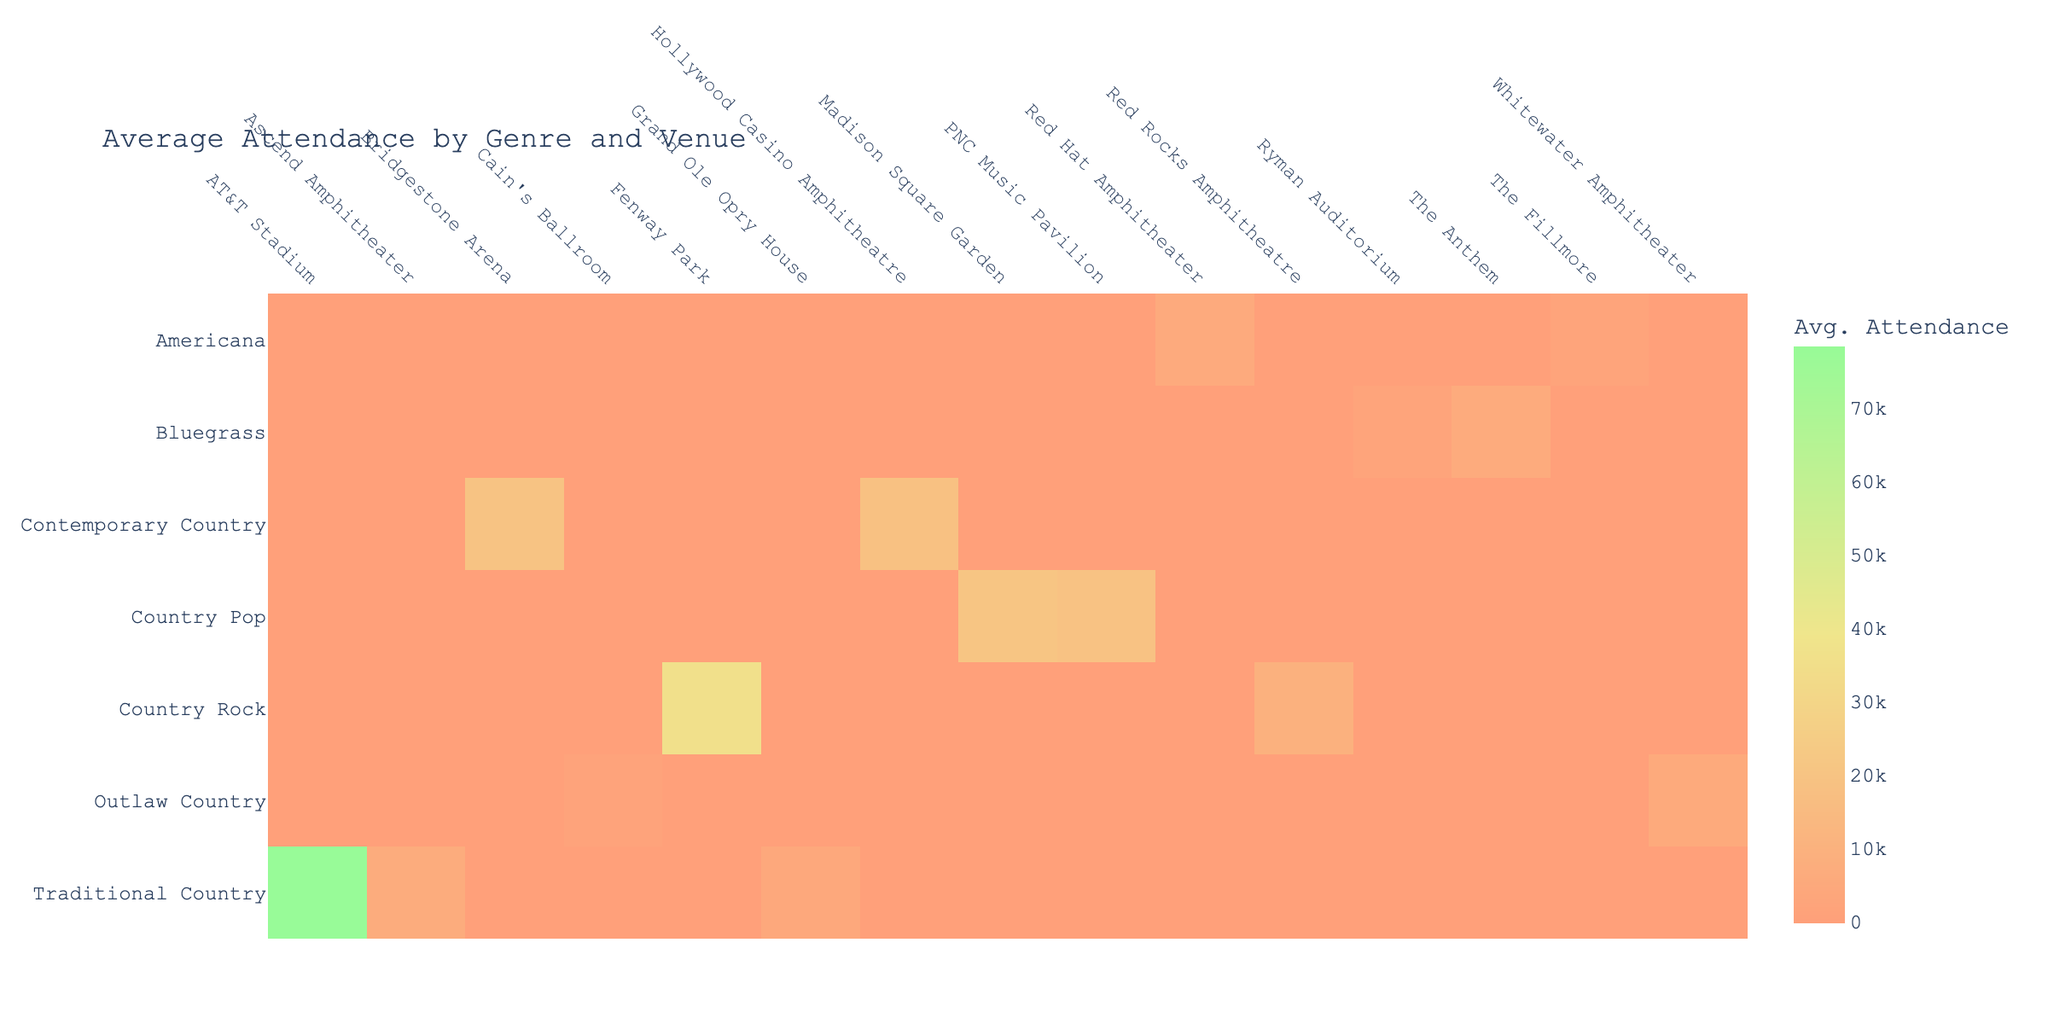What is the average attendance for Traditional Country concerts? To find the average attendance for Traditional Country concerts, we look at the attendance values for the artists in that genre, which are: George Strait (78500), Alan Jackson (4350), and Dolly Parton (6750). We sum these values: 78500 + 4350 + 6750 = 88500, and then divide by the number of concerts held (3). Thus, 88500 / 3 = 29500.
Answer: 29500 Which venue had the highest average attendance across all genres? To determine the venue with the highest average attendance, we look at the average attendance for each venue. The values are: AT&T Stadium (78500), Bridgestone Arena (19800), Red Rocks Amphitheatre (9450), Ryman Auditorium (2300), Whitewater Amphitheater (5400), Madison Square Garden (20500), The Fillmore (2450), Grand Ole Opry House (4350), Hollywood Casino Amphitheatre (18500), Fenway Park (36000), The Anthem (5900), Cain's Ballroom (1750), PNC Music Pavilion (19000), Red Hat Amphitheater (5800), and Ascend Amphitheater (6750). The highest value among these is for AT&T Stadium at 78500.
Answer: AT&T Stadium Is there any venue where all concerts had attendance lower than its capacity? To find such venues, we need to check each attendance against its capacity. For all concerts where attendance is less than capacity: AT&T Stadium (78500 vs 80000), Bridgestone Arena (19800 vs 20000), Red Rocks Amphitheatre (9450 vs 9500), Ryman Auditorium (2300 vs 2362), Whitewater Amphitheater (5400 vs 5600), Madison Square Garden (20500 vs 20789), The Fillmore (2450 vs 2500), Grand Ole Opry House (4350 vs 4400), Hollywood Casino Amphitheatre (18500 vs 19000), Fenway Park (36000 vs 37731), The Anthem (5900 vs 6000), Cain's Ballroom (1750 vs 1800), PNC Music Pavilion (19000 vs 19500), Red Hat Amphitheater (5800 vs 5990), Ascend Amphitheater (6750 vs 6800). Since all venues have at least one concert with attendance lower than capacity, the answer is yes.
Answer: Yes What is the total attendance for concerts held in Nashville? To calculate the total attendance for concerts in Nashville, we list the artists and their attendance from that city: Luke Bryan (19800), Alison Krauss (2300), Alan Jackson (4350), Miranda Lambert (18500), Dolly Parton (6750). We sum these values: 19800 + 2300 + 4350 + 18500 + 6750 = 51000.
Answer: 51000 Which genre had the lowest average attendance overall? We need to calculate the average attendance for each genre by summing the attendance values and dividing by the number of concerts for each genre. The averages are: Traditional Country (29500), Contemporary Country (19150), Country Rock (22725), Bluegrass (1450), Outlaw Country (3650), Country Pop (19750), Americana (3290). The genre with the lowest average is Bluegrass at 1450.
Answer: Bluegrass 